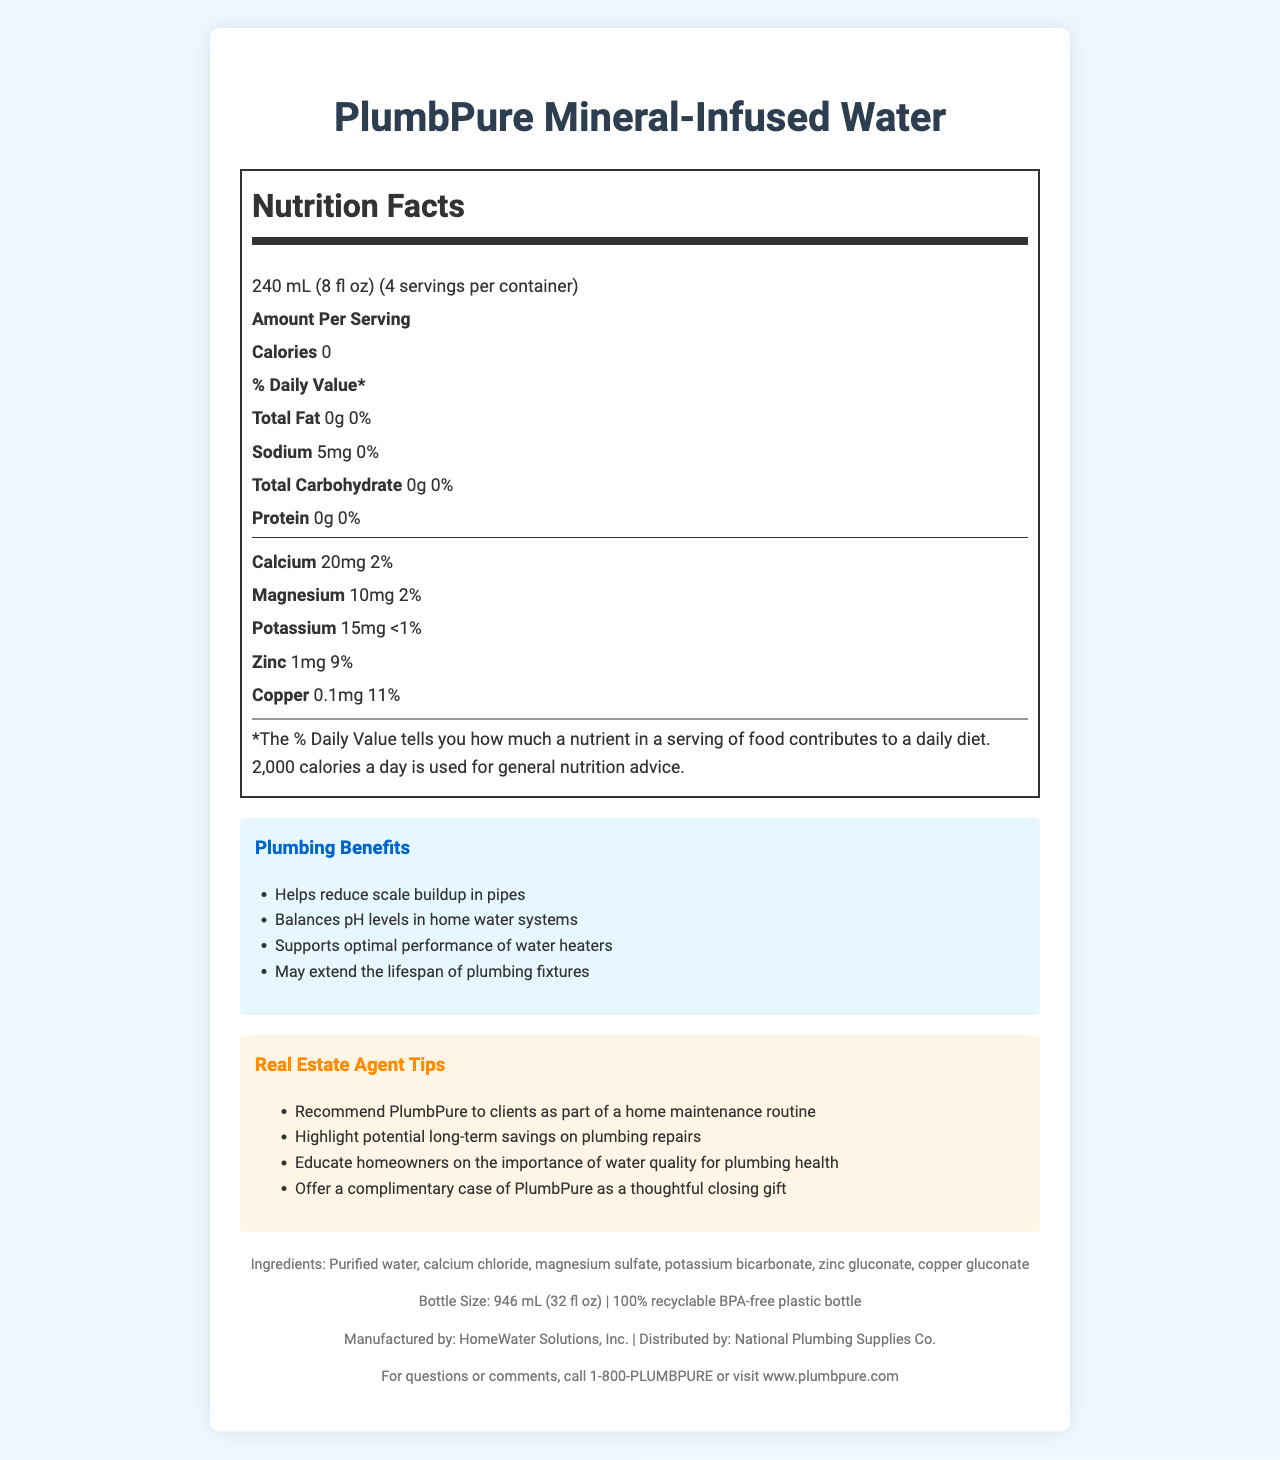what is the product name? The document title clearly displays the product name as "PlumbPure Mineral-Infused Water."
Answer: PlumbPure Mineral-Infused Water How many calories are in one serving of this water? The Nutrition Facts section states that there are 0 calories per serving.
Answer: 0 What minerals are included in this water, and what are their amounts per serving? The Nutrition Facts section lists the mineral content and their respective amounts per serving.
Answer: Calcium: 20mg, Magnesium: 10mg, Potassium: 15mg, Zinc: 1mg, Copper: 0.1mg How do the minerals in this water benefit home plumbing systems? These benefits are listed in the section titled "Plumbing Benefits."
Answer: Helps reduce scale buildup in pipes, Balances pH levels in home water systems, Supports optimal performance of water heaters, May extend the lifespan of plumbing fixtures What is the recommended serving size for this product? The Nutrition Facts section specifies the serving size as 240 mL (8 fl oz).
Answer: 240 mL (8 fl oz) What is the total number of servings per container? The Nutrition Facts lists that there are 4 servings per container.
Answer: 4 What company manufactures PlumbPure Mineral-Infused Water? The footer section of the document states that it is manufactured by HomeWater Solutions, Inc.
Answer: HomeWater Solutions, Inc. Which of the following is a benefit of using PlumbPure for home plumbing? A. Increases water pressure B. Helps reduce scale buildup in pipes C. Makes water taste better D. Adds chlorine to water The "Plumbing Benefits" section lists "Helps reduce scale buildup in pipes" as one of the benefits.
Answer: B What percentage of the daily value of Copper does one serving of this water provide? A. 2% B. 9% C. 11% D. 5% According to the mineral content section, Copper provides 11% of the daily value per serving.
Answer: C Is the bottle for PlumbPure Mineral-Infused Water recyclable? The footer mentions that the bottle is made from 100% recyclable BPA-free plastic.
Answer: Yes Summarize the main idea of the document. The document contains detailed descriptions of the product’s nutritional value, mineral benefits for plumbing, and advice for real estate agents to promote the product in their professional dealings.
Answer: The document provides the nutrition facts and benefits of PlumbPure Mineral-Infused Water, highlighting its essential mineral content and its advantages for maintaining home plumbing systems. It also offers tips for real estate agents on how to recommend this product to clients. Where is National Plumbing Supplies Co. located? The document does not provide the location for National Plumbing Supplies Co. It only mentions that they distribute the product.
Answer: Cannot be determined 